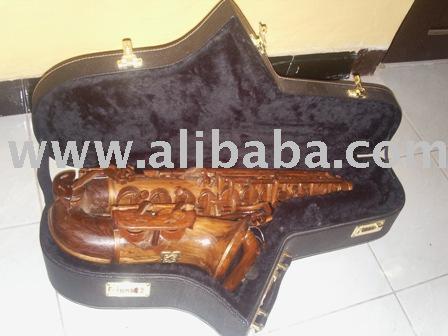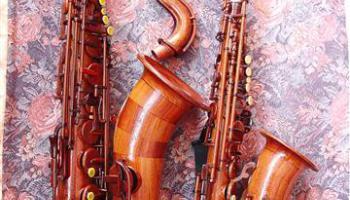The first image is the image on the left, the second image is the image on the right. Considering the images on both sides, is "In one of the images there are two saxophones placed next to each other." valid? Answer yes or no. Yes. 